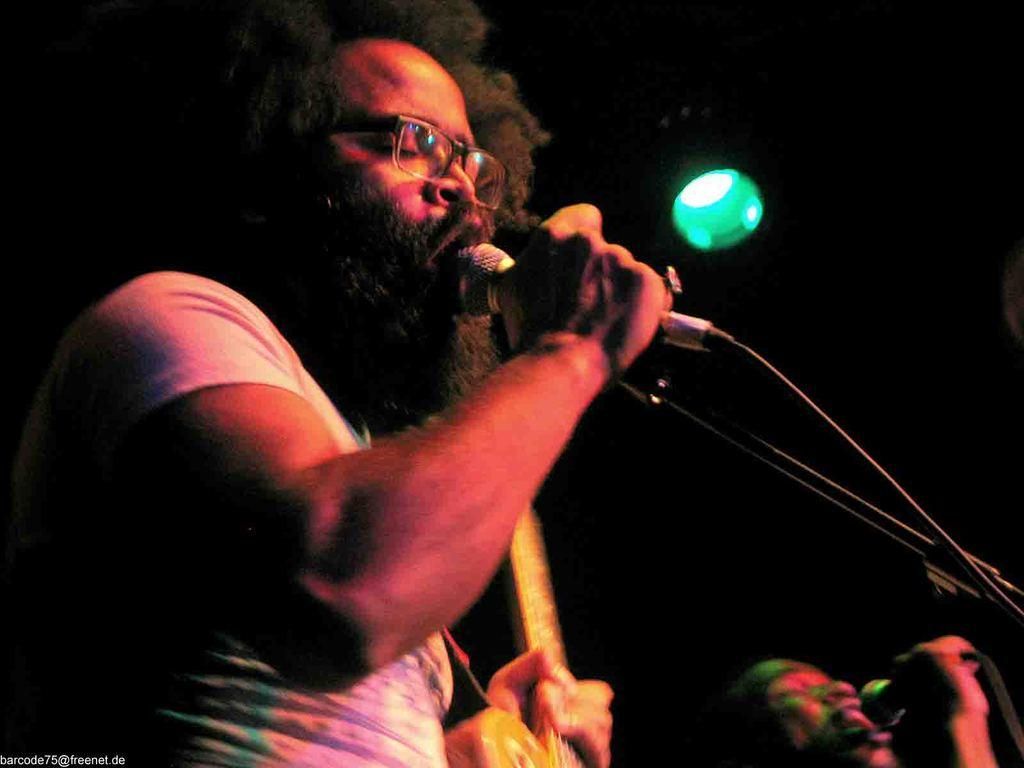How many people are in the image? There are two men in the image. What are the men doing in the image? The men are singing in the image. What are the men holding while singing? The men are holding microphones in the image. What can be seen in the image besides the men and microphones? There is a musical instrument and a focusing light visible in the image. What is the color of the background in the image? The background of the image is dark. What type of underwear is the man on the left wearing in the image? There is no information about the men's underwear in the image, so it cannot be determined. What sound can be heard from the bells in the image? There are no bells present in the image, so no sound can be heard from them. 